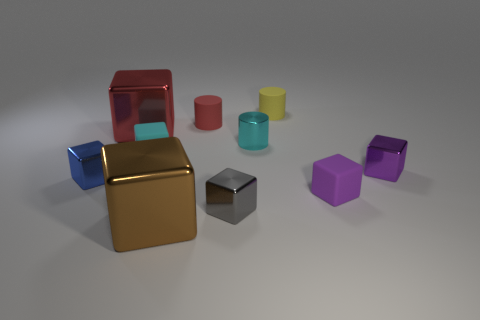There is a block on the left side of the large metallic object that is to the left of the rubber cube left of the yellow rubber thing; what is it made of?
Offer a very short reply. Metal. How many other objects are the same size as the cyan shiny thing?
Make the answer very short. 7. There is a big object behind the small cyan object to the left of the small gray block; how many blue shiny objects are in front of it?
Provide a short and direct response. 1. There is a purple object in front of the tiny metallic block that is behind the small blue metal object; what is it made of?
Ensure brevity in your answer.  Rubber. Is there a big cyan object that has the same shape as the big red metal thing?
Offer a very short reply. No. There is another rubber block that is the same size as the purple matte block; what color is it?
Your answer should be very brief. Cyan. What number of objects are either rubber objects that are to the left of the tiny cyan metallic object or small purple cubes in front of the tiny blue metal block?
Your response must be concise. 3. What number of objects are big red balls or tiny objects?
Offer a terse response. 8. What is the size of the object that is both to the left of the small cyan matte cube and behind the small cyan metallic cylinder?
Make the answer very short. Large. What number of tiny red cylinders have the same material as the gray cube?
Ensure brevity in your answer.  0. 